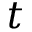Convert formula to latex. <formula><loc_0><loc_0><loc_500><loc_500>t</formula> 